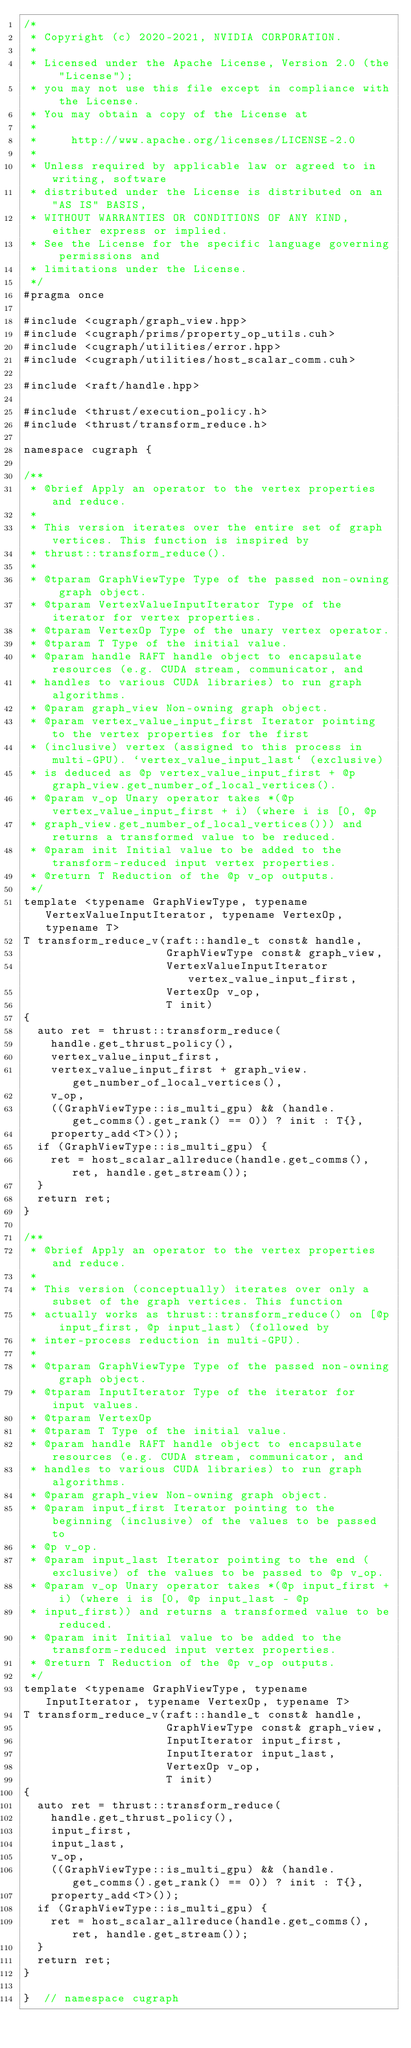Convert code to text. <code><loc_0><loc_0><loc_500><loc_500><_Cuda_>/*
 * Copyright (c) 2020-2021, NVIDIA CORPORATION.
 *
 * Licensed under the Apache License, Version 2.0 (the "License");
 * you may not use this file except in compliance with the License.
 * You may obtain a copy of the License at
 *
 *     http://www.apache.org/licenses/LICENSE-2.0
 *
 * Unless required by applicable law or agreed to in writing, software
 * distributed under the License is distributed on an "AS IS" BASIS,
 * WITHOUT WARRANTIES OR CONDITIONS OF ANY KIND, either express or implied.
 * See the License for the specific language governing permissions and
 * limitations under the License.
 */
#pragma once

#include <cugraph/graph_view.hpp>
#include <cugraph/prims/property_op_utils.cuh>
#include <cugraph/utilities/error.hpp>
#include <cugraph/utilities/host_scalar_comm.cuh>

#include <raft/handle.hpp>

#include <thrust/execution_policy.h>
#include <thrust/transform_reduce.h>

namespace cugraph {

/**
 * @brief Apply an operator to the vertex properties and reduce.
 *
 * This version iterates over the entire set of graph vertices. This function is inspired by
 * thrust::transform_reduce().
 *
 * @tparam GraphViewType Type of the passed non-owning graph object.
 * @tparam VertexValueInputIterator Type of the iterator for vertex properties.
 * @tparam VertexOp Type of the unary vertex operator.
 * @tparam T Type of the initial value.
 * @param handle RAFT handle object to encapsulate resources (e.g. CUDA stream, communicator, and
 * handles to various CUDA libraries) to run graph algorithms.
 * @param graph_view Non-owning graph object.
 * @param vertex_value_input_first Iterator pointing to the vertex properties for the first
 * (inclusive) vertex (assigned to this process in multi-GPU). `vertex_value_input_last` (exclusive)
 * is deduced as @p vertex_value_input_first + @p graph_view.get_number_of_local_vertices().
 * @param v_op Unary operator takes *(@p vertex_value_input_first + i) (where i is [0, @p
 * graph_view.get_number_of_local_vertices())) and returns a transformed value to be reduced.
 * @param init Initial value to be added to the transform-reduced input vertex properties.
 * @return T Reduction of the @p v_op outputs.
 */
template <typename GraphViewType, typename VertexValueInputIterator, typename VertexOp, typename T>
T transform_reduce_v(raft::handle_t const& handle,
                     GraphViewType const& graph_view,
                     VertexValueInputIterator vertex_value_input_first,
                     VertexOp v_op,
                     T init)
{
  auto ret = thrust::transform_reduce(
    handle.get_thrust_policy(),
    vertex_value_input_first,
    vertex_value_input_first + graph_view.get_number_of_local_vertices(),
    v_op,
    ((GraphViewType::is_multi_gpu) && (handle.get_comms().get_rank() == 0)) ? init : T{},
    property_add<T>());
  if (GraphViewType::is_multi_gpu) {
    ret = host_scalar_allreduce(handle.get_comms(), ret, handle.get_stream());
  }
  return ret;
}

/**
 * @brief Apply an operator to the vertex properties and reduce.
 *
 * This version (conceptually) iterates over only a subset of the graph vertices. This function
 * actually works as thrust::transform_reduce() on [@p input_first, @p input_last) (followed by
 * inter-process reduction in multi-GPU).
 *
 * @tparam GraphViewType Type of the passed non-owning graph object.
 * @tparam InputIterator Type of the iterator for input values.
 * @tparam VertexOp
 * @tparam T Type of the initial value.
 * @param handle RAFT handle object to encapsulate resources (e.g. CUDA stream, communicator, and
 * handles to various CUDA libraries) to run graph algorithms.
 * @param graph_view Non-owning graph object.
 * @param input_first Iterator pointing to the beginning (inclusive) of the values to be passed to
 * @p v_op.
 * @param input_last Iterator pointing to the end (exclusive) of the values to be passed to @p v_op.
 * @param v_op Unary operator takes *(@p input_first + i) (where i is [0, @p input_last - @p
 * input_first)) and returns a transformed value to be reduced.
 * @param init Initial value to be added to the transform-reduced input vertex properties.
 * @return T Reduction of the @p v_op outputs.
 */
template <typename GraphViewType, typename InputIterator, typename VertexOp, typename T>
T transform_reduce_v(raft::handle_t const& handle,
                     GraphViewType const& graph_view,
                     InputIterator input_first,
                     InputIterator input_last,
                     VertexOp v_op,
                     T init)
{
  auto ret = thrust::transform_reduce(
    handle.get_thrust_policy(),
    input_first,
    input_last,
    v_op,
    ((GraphViewType::is_multi_gpu) && (handle.get_comms().get_rank() == 0)) ? init : T{},
    property_add<T>());
  if (GraphViewType::is_multi_gpu) {
    ret = host_scalar_allreduce(handle.get_comms(), ret, handle.get_stream());
  }
  return ret;
}

}  // namespace cugraph
</code> 